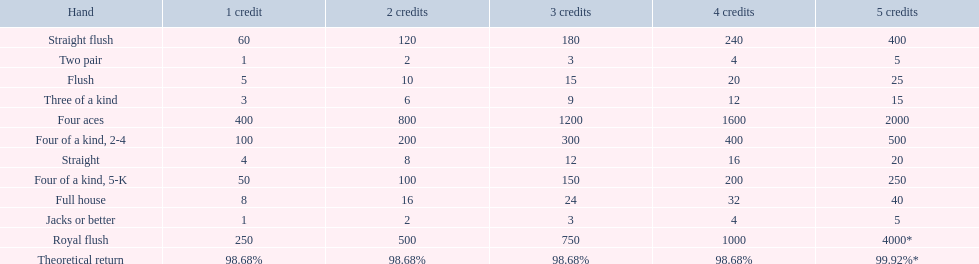Which hand is lower than straight flush? Four aces. Which hand is lower than four aces? Four of a kind, 2-4. Which hand is higher out of straight and flush? Flush. 